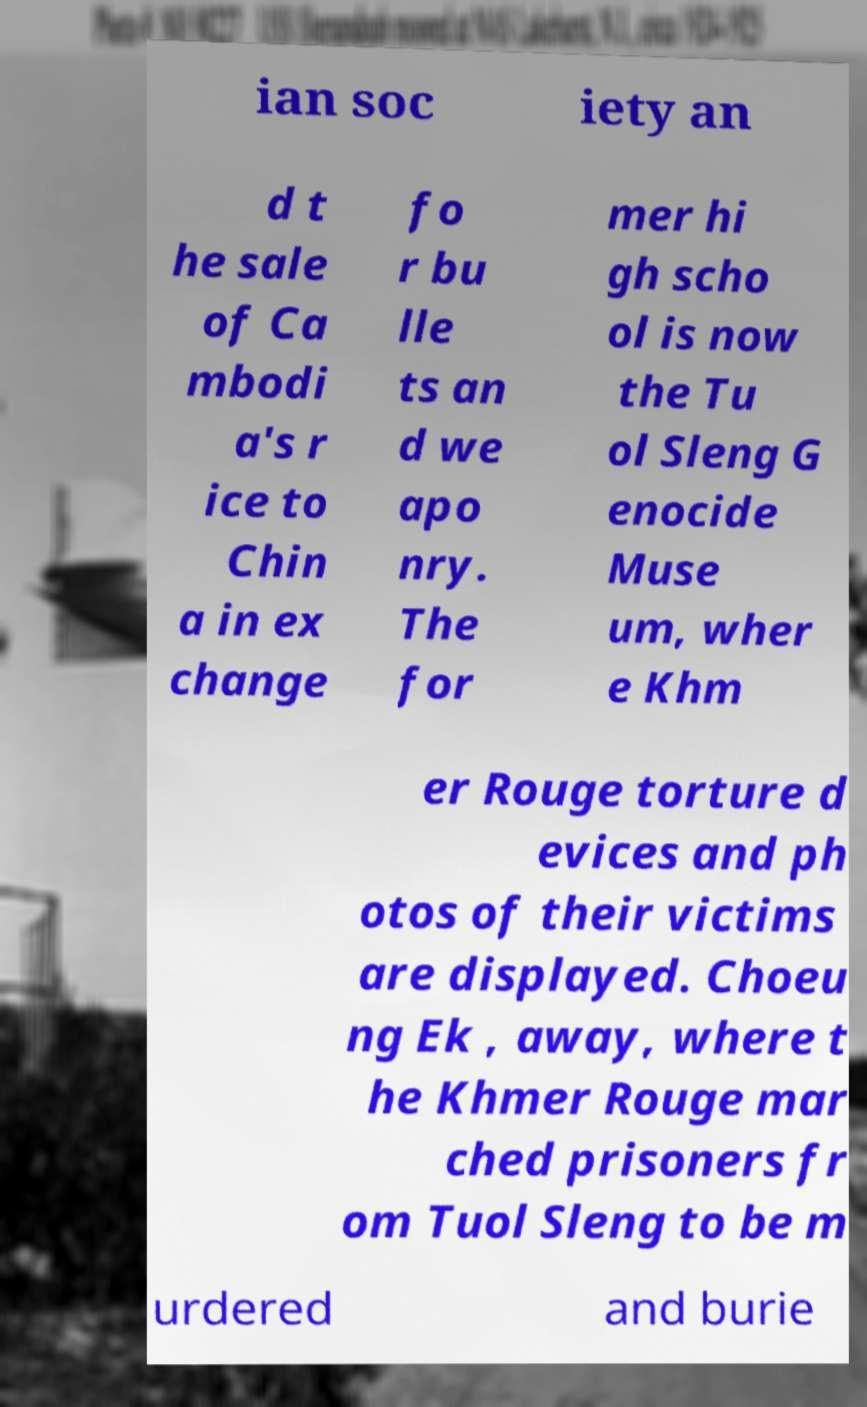Could you extract and type out the text from this image? ian soc iety an d t he sale of Ca mbodi a's r ice to Chin a in ex change fo r bu lle ts an d we apo nry. The for mer hi gh scho ol is now the Tu ol Sleng G enocide Muse um, wher e Khm er Rouge torture d evices and ph otos of their victims are displayed. Choeu ng Ek , away, where t he Khmer Rouge mar ched prisoners fr om Tuol Sleng to be m urdered and burie 